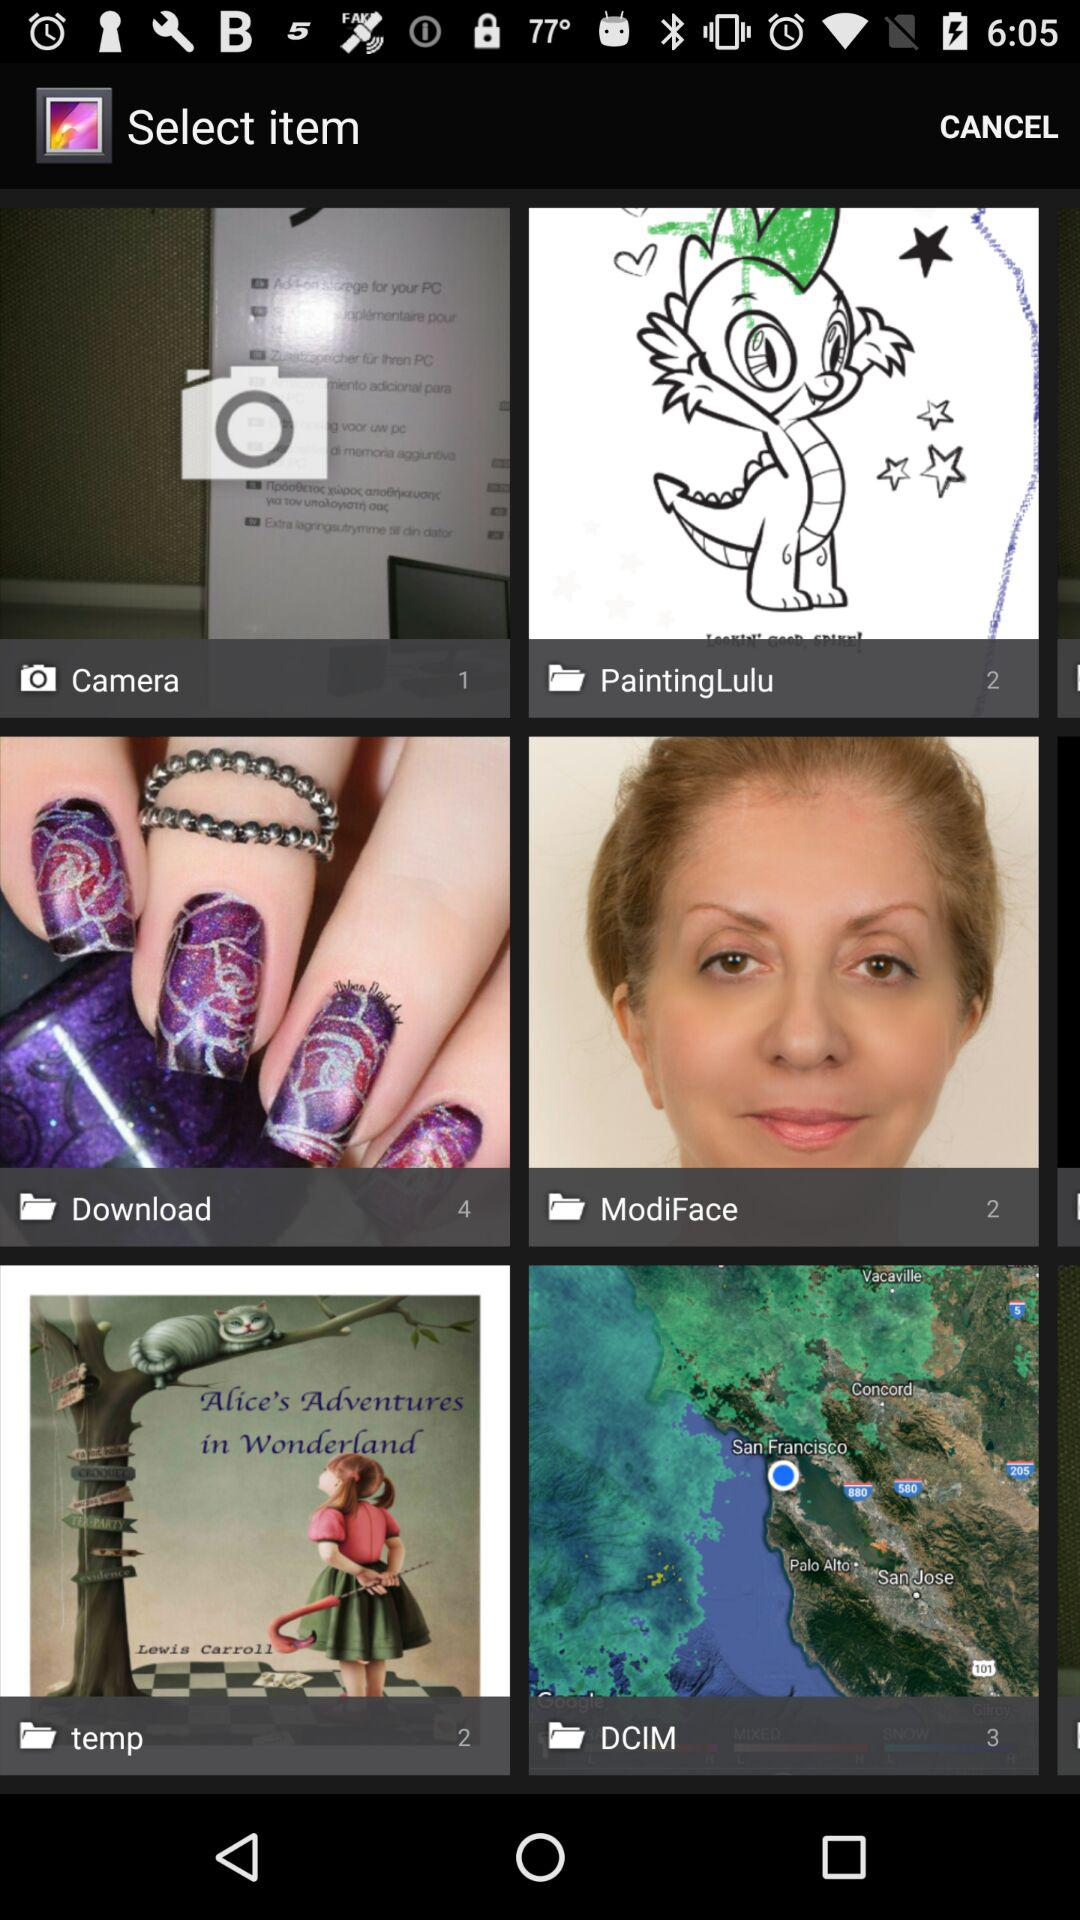How many images are in the "ModiFace" folder? There are 2 images in the "ModiFace" folder. 